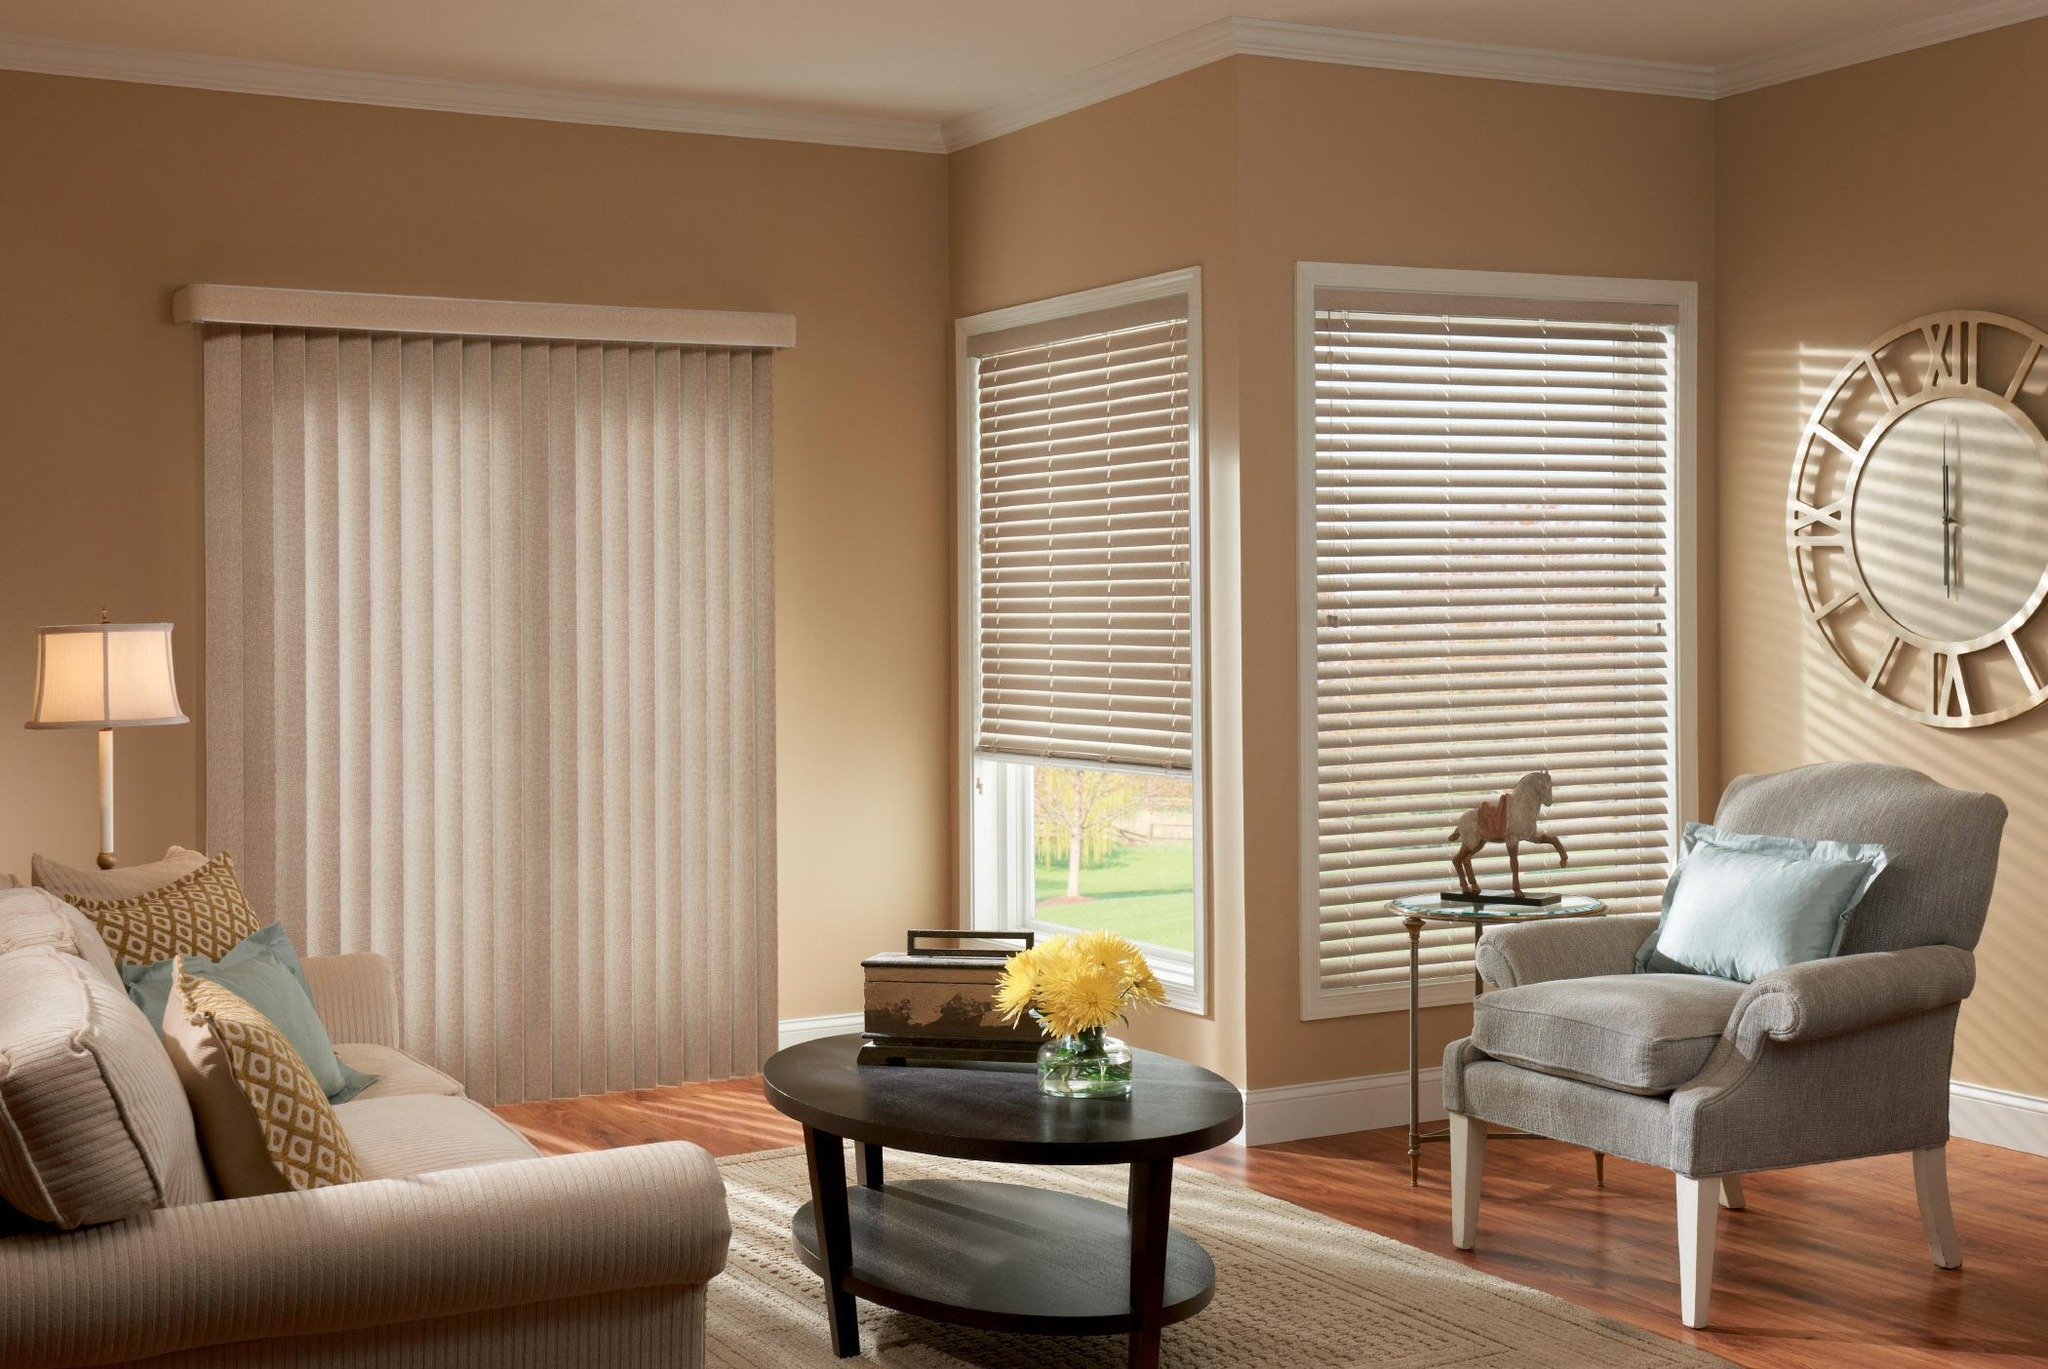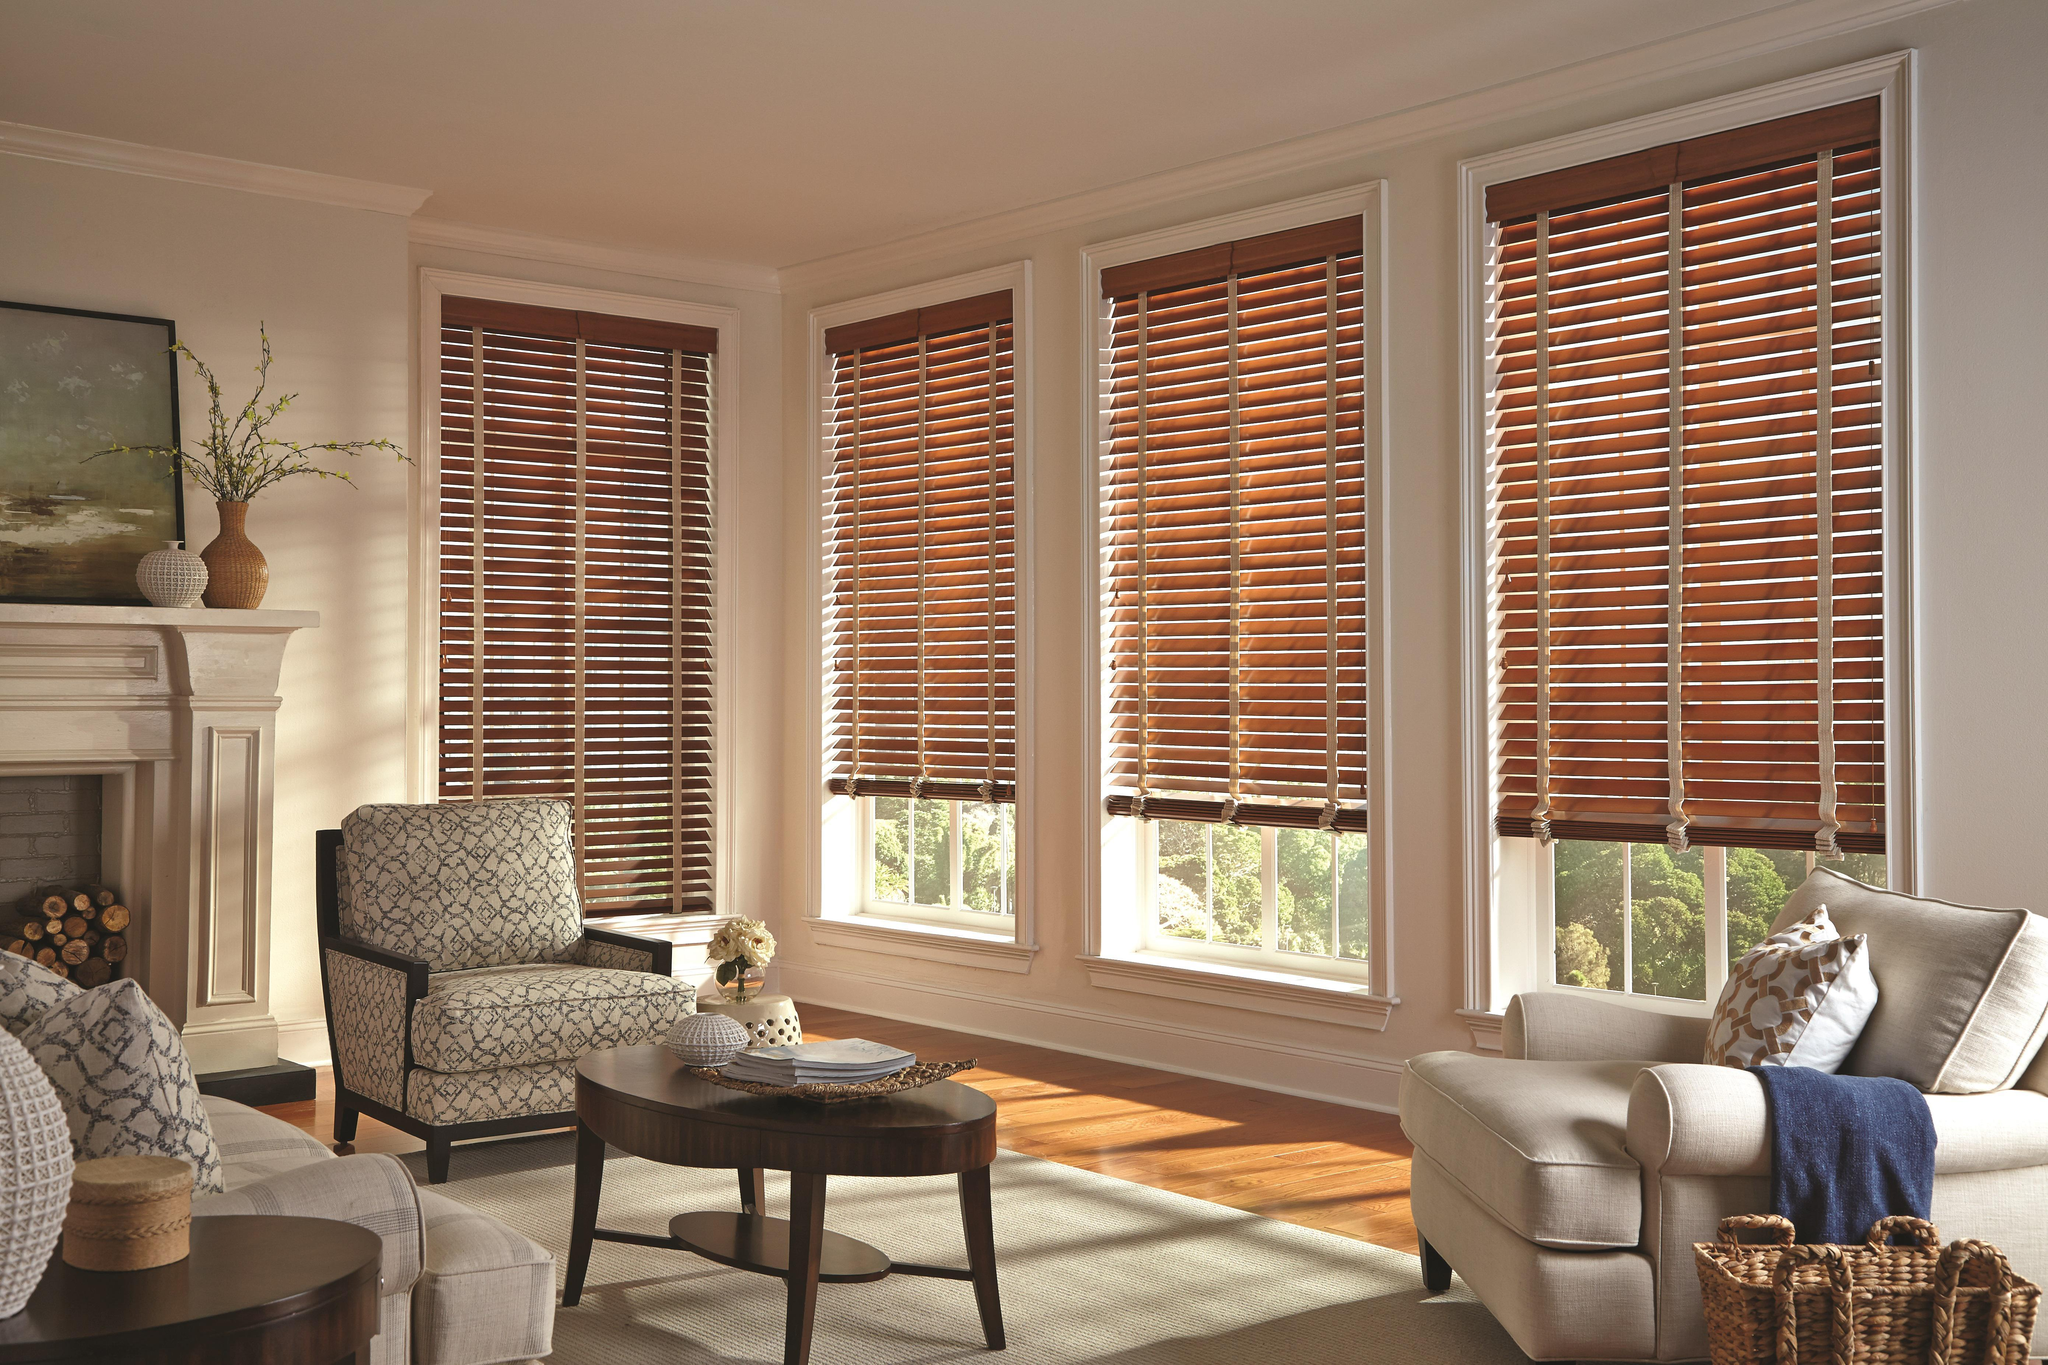The first image is the image on the left, the second image is the image on the right. Examine the images to the left and right. Is the description "There is a total of seven shades." accurate? Answer yes or no. Yes. The first image is the image on the left, the second image is the image on the right. For the images shown, is this caption "A window blind is partially pulled up in both images." true? Answer yes or no. Yes. 